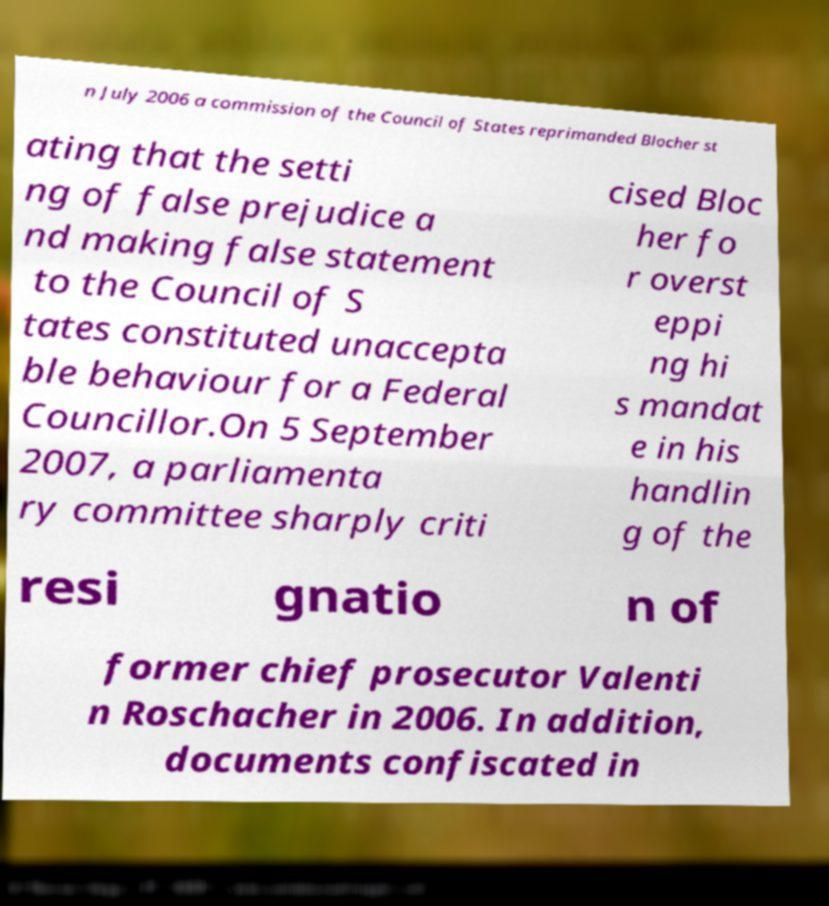Can you read and provide the text displayed in the image?This photo seems to have some interesting text. Can you extract and type it out for me? n July 2006 a commission of the Council of States reprimanded Blocher st ating that the setti ng of false prejudice a nd making false statement to the Council of S tates constituted unaccepta ble behaviour for a Federal Councillor.On 5 September 2007, a parliamenta ry committee sharply criti cised Bloc her fo r overst eppi ng hi s mandat e in his handlin g of the resi gnatio n of former chief prosecutor Valenti n Roschacher in 2006. In addition, documents confiscated in 